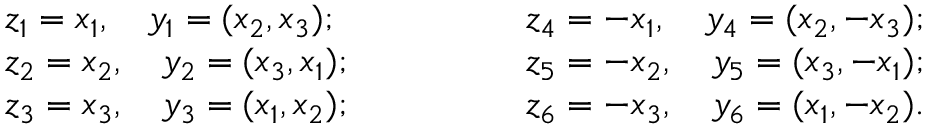Convert formula to latex. <formula><loc_0><loc_0><loc_500><loc_500>\begin{array} { l } { z _ { 1 } = x _ { 1 } , \quad y _ { 1 } = ( x _ { 2 } , x _ { 3 } ) ; } \\ { z _ { 2 } = x _ { 2 } , \quad y _ { 2 } = ( x _ { 3 } , x _ { 1 } ) ; } \\ { z _ { 3 } = x _ { 3 } , \quad y _ { 3 } = ( x _ { 1 } , x _ { 2 } ) ; } \end{array} \quad \begin{array} { l } { z _ { 4 } = - x _ { 1 } , \quad y _ { 4 } = ( x _ { 2 } , - x _ { 3 } ) ; } \\ { z _ { 5 } = - x _ { 2 } , \quad y _ { 5 } = ( x _ { 3 } , - x _ { 1 } ) ; } \\ { z _ { 6 } = - x _ { 3 } , \quad y _ { 6 } = ( x _ { 1 } , - x _ { 2 } ) . } \end{array}</formula> 